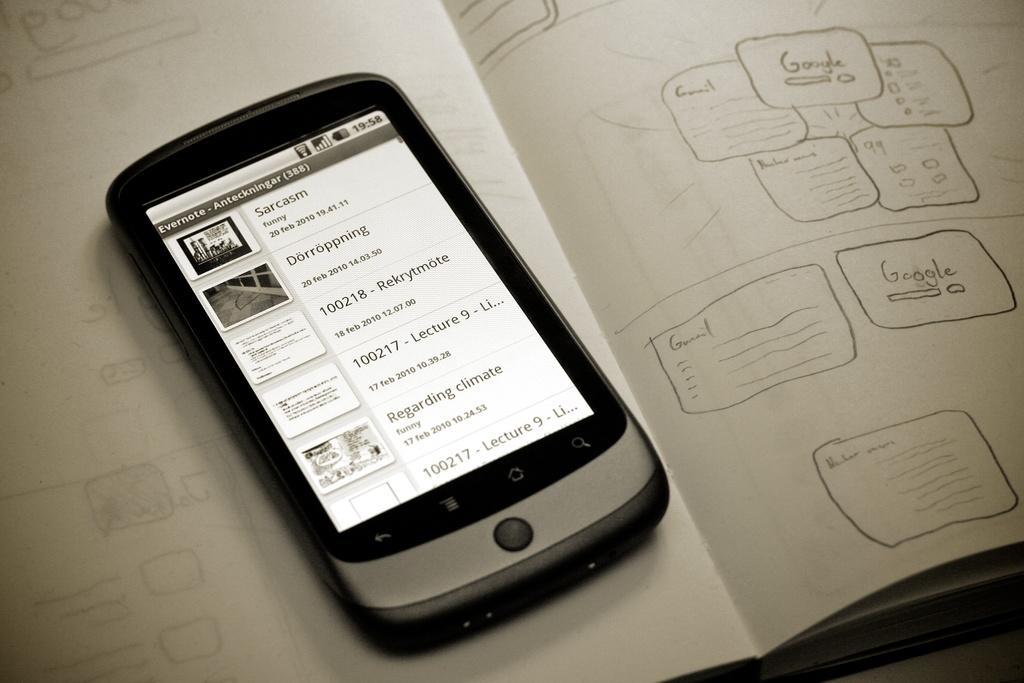<image>
Render a clear and concise summary of the photo. A gray cellphone with the time displaying 19:58 in the screen 